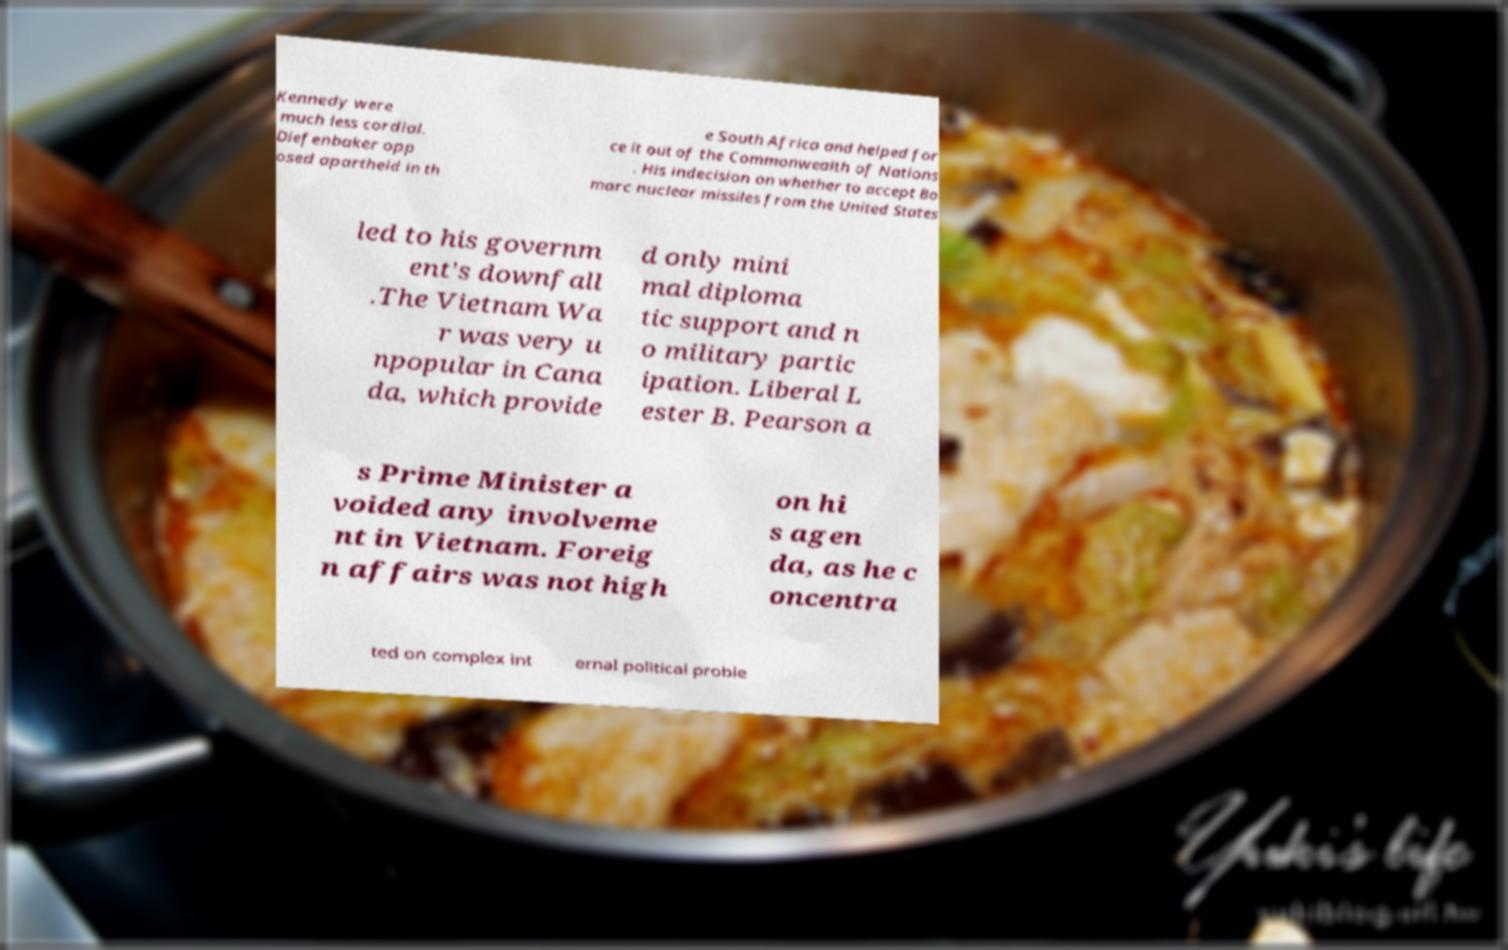Could you assist in decoding the text presented in this image and type it out clearly? Kennedy were much less cordial. Diefenbaker opp osed apartheid in th e South Africa and helped for ce it out of the Commonwealth of Nations . His indecision on whether to accept Bo marc nuclear missiles from the United States led to his governm ent's downfall .The Vietnam Wa r was very u npopular in Cana da, which provide d only mini mal diploma tic support and n o military partic ipation. Liberal L ester B. Pearson a s Prime Minister a voided any involveme nt in Vietnam. Foreig n affairs was not high on hi s agen da, as he c oncentra ted on complex int ernal political proble 